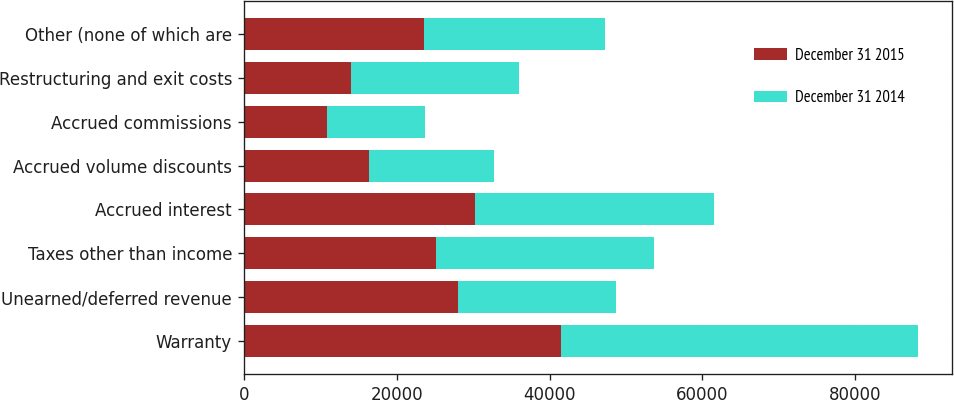Convert chart. <chart><loc_0><loc_0><loc_500><loc_500><stacked_bar_chart><ecel><fcel>Warranty<fcel>Unearned/deferred revenue<fcel>Taxes other than income<fcel>Accrued interest<fcel>Accrued volume discounts<fcel>Accrued commissions<fcel>Restructuring and exit costs<fcel>Other (none of which are<nl><fcel>December 31 2015<fcel>41502<fcel>28072<fcel>25180<fcel>30262<fcel>16402<fcel>10949<fcel>13991<fcel>23600.5<nl><fcel>December 31 2014<fcel>46704<fcel>20678<fcel>28452<fcel>31318<fcel>16352<fcel>12799<fcel>22021<fcel>23600.5<nl></chart> 